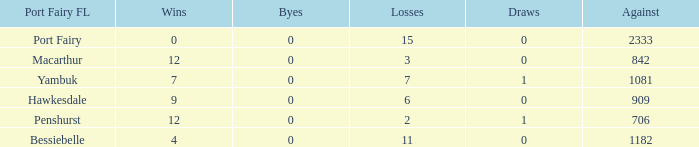Could you parse the entire table? {'header': ['Port Fairy FL', 'Wins', 'Byes', 'Losses', 'Draws', 'Against'], 'rows': [['Port Fairy', '0', '0', '15', '0', '2333'], ['Macarthur', '12', '0', '3', '0', '842'], ['Yambuk', '7', '0', '7', '1', '1081'], ['Hawkesdale', '9', '0', '6', '0', '909'], ['Penshurst', '12', '0', '2', '1', '706'], ['Bessiebelle', '4', '0', '11', '0', '1182']]} When hawkesdale achieves greater than 9 wins in the port fairy fl, what is the number of draws? None. 